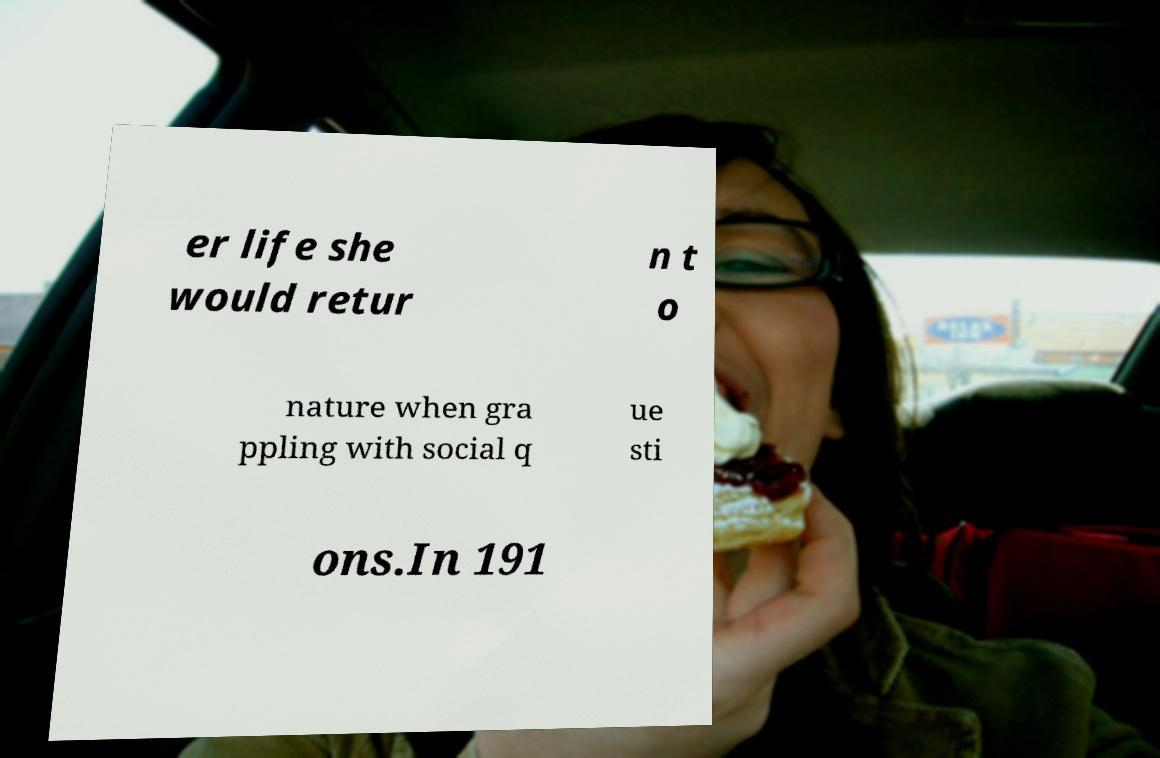Please identify and transcribe the text found in this image. er life she would retur n t o nature when gra ppling with social q ue sti ons.In 191 